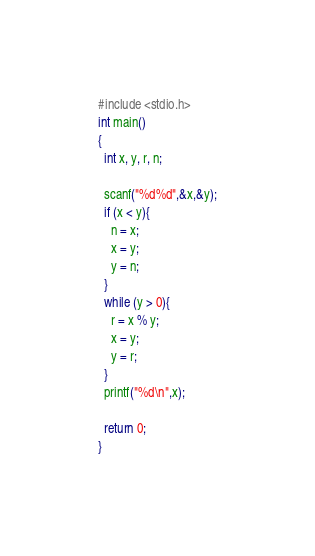<code> <loc_0><loc_0><loc_500><loc_500><_C_>#include <stdio.h>
int main()
{
  int x, y, r, n;

  scanf("%d%d",&x,&y);
  if (x < y){
    n = x;
    x = y;
    y = n;
  }
  while (y > 0){
    r = x % y;
    x = y;
    y = r;
  }
  printf("%d\n",x);
  
  return 0;
}

</code> 